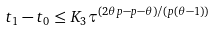<formula> <loc_0><loc_0><loc_500><loc_500>t _ { 1 } - t _ { 0 } \leq K _ { 3 } \tau ^ { ( 2 \theta p - p - \theta ) / ( p ( \theta - 1 ) ) }</formula> 